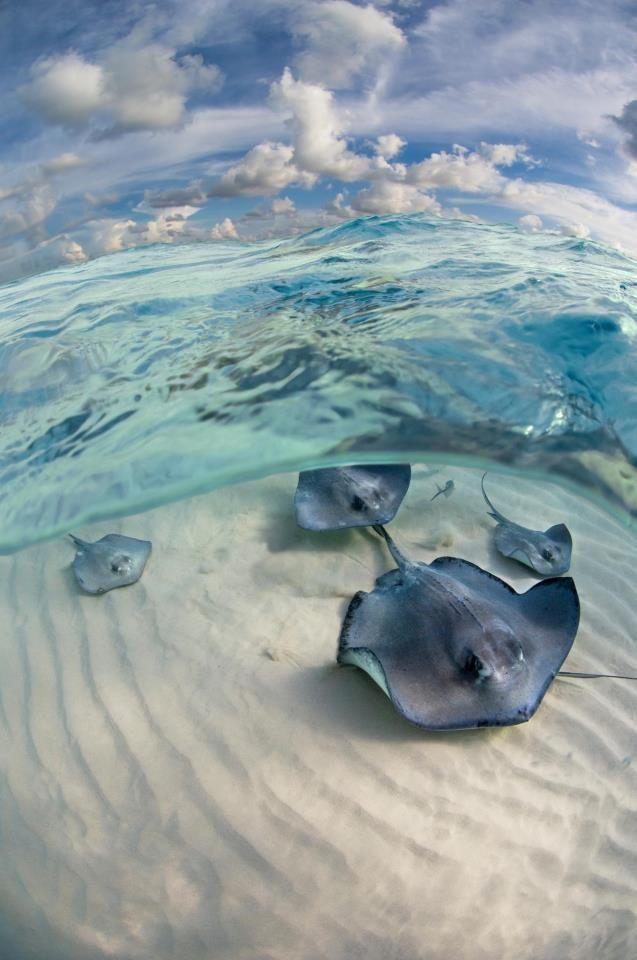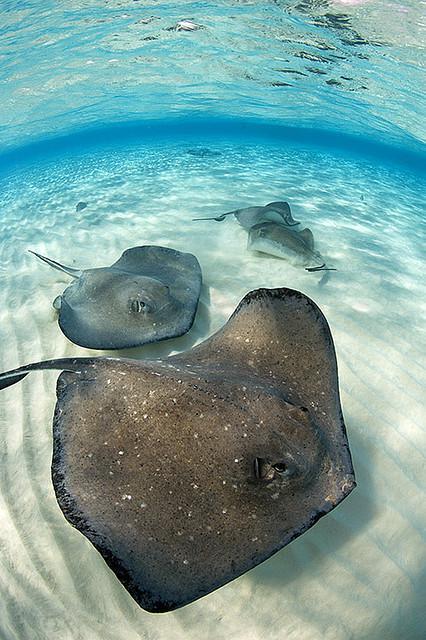The first image is the image on the left, the second image is the image on the right. Given the left and right images, does the statement "At least one human is in the ocean with the fish in one of the images." hold true? Answer yes or no. No. The first image is the image on the left, the second image is the image on the right. Evaluate the accuracy of this statement regarding the images: "In one image, at least one person is in the water interacting with a stingray, and a snorkel is visible.". Is it true? Answer yes or no. No. 